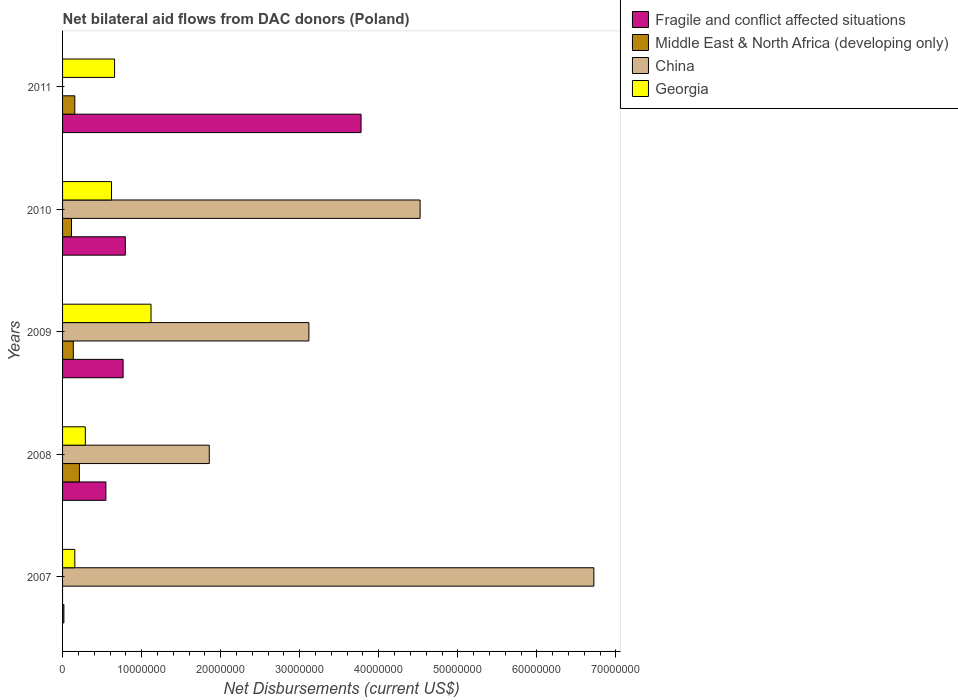Are the number of bars per tick equal to the number of legend labels?
Keep it short and to the point. No. Are the number of bars on each tick of the Y-axis equal?
Provide a succinct answer. No. How many bars are there on the 5th tick from the top?
Your response must be concise. 3. What is the label of the 2nd group of bars from the top?
Offer a very short reply. 2010. In how many cases, is the number of bars for a given year not equal to the number of legend labels?
Offer a very short reply. 2. What is the net bilateral aid flows in Fragile and conflict affected situations in 2010?
Your response must be concise. 7.94e+06. Across all years, what is the maximum net bilateral aid flows in China?
Keep it short and to the point. 6.72e+07. Across all years, what is the minimum net bilateral aid flows in Fragile and conflict affected situations?
Keep it short and to the point. 1.70e+05. What is the total net bilateral aid flows in Middle East & North Africa (developing only) in the graph?
Provide a short and direct response. 6.17e+06. What is the difference between the net bilateral aid flows in Fragile and conflict affected situations in 2007 and that in 2011?
Your answer should be compact. -3.76e+07. What is the difference between the net bilateral aid flows in China in 2010 and the net bilateral aid flows in Middle East & North Africa (developing only) in 2007?
Make the answer very short. 4.52e+07. What is the average net bilateral aid flows in Fragile and conflict affected situations per year?
Keep it short and to the point. 1.18e+07. In the year 2010, what is the difference between the net bilateral aid flows in Georgia and net bilateral aid flows in Fragile and conflict affected situations?
Make the answer very short. -1.75e+06. In how many years, is the net bilateral aid flows in China greater than 10000000 US$?
Your answer should be compact. 4. What is the ratio of the net bilateral aid flows in Middle East & North Africa (developing only) in 2008 to that in 2011?
Give a very brief answer. 1.37. Is the net bilateral aid flows in China in 2007 less than that in 2009?
Provide a short and direct response. No. Is the difference between the net bilateral aid flows in Georgia in 2008 and 2009 greater than the difference between the net bilateral aid flows in Fragile and conflict affected situations in 2008 and 2009?
Your response must be concise. No. What is the difference between the highest and the second highest net bilateral aid flows in Middle East & North Africa (developing only)?
Your answer should be very brief. 5.80e+05. What is the difference between the highest and the lowest net bilateral aid flows in China?
Make the answer very short. 6.72e+07. In how many years, is the net bilateral aid flows in Middle East & North Africa (developing only) greater than the average net bilateral aid flows in Middle East & North Africa (developing only) taken over all years?
Ensure brevity in your answer.  3. Is it the case that in every year, the sum of the net bilateral aid flows in Georgia and net bilateral aid flows in Fragile and conflict affected situations is greater than the net bilateral aid flows in Middle East & North Africa (developing only)?
Make the answer very short. Yes. What is the difference between two consecutive major ticks on the X-axis?
Your answer should be compact. 1.00e+07. Does the graph contain any zero values?
Offer a very short reply. Yes. What is the title of the graph?
Ensure brevity in your answer.  Net bilateral aid flows from DAC donors (Poland). Does "Poland" appear as one of the legend labels in the graph?
Keep it short and to the point. No. What is the label or title of the X-axis?
Your answer should be compact. Net Disbursements (current US$). What is the Net Disbursements (current US$) in Fragile and conflict affected situations in 2007?
Ensure brevity in your answer.  1.70e+05. What is the Net Disbursements (current US$) in Middle East & North Africa (developing only) in 2007?
Offer a terse response. 0. What is the Net Disbursements (current US$) in China in 2007?
Offer a very short reply. 6.72e+07. What is the Net Disbursements (current US$) in Georgia in 2007?
Provide a short and direct response. 1.55e+06. What is the Net Disbursements (current US$) in Fragile and conflict affected situations in 2008?
Your response must be concise. 5.48e+06. What is the Net Disbursements (current US$) in Middle East & North Africa (developing only) in 2008?
Offer a terse response. 2.13e+06. What is the Net Disbursements (current US$) of China in 2008?
Provide a short and direct response. 1.86e+07. What is the Net Disbursements (current US$) of Georgia in 2008?
Provide a succinct answer. 2.88e+06. What is the Net Disbursements (current US$) of Fragile and conflict affected situations in 2009?
Give a very brief answer. 7.66e+06. What is the Net Disbursements (current US$) in Middle East & North Africa (developing only) in 2009?
Provide a short and direct response. 1.36e+06. What is the Net Disbursements (current US$) in China in 2009?
Your response must be concise. 3.12e+07. What is the Net Disbursements (current US$) in Georgia in 2009?
Make the answer very short. 1.12e+07. What is the Net Disbursements (current US$) in Fragile and conflict affected situations in 2010?
Your answer should be compact. 7.94e+06. What is the Net Disbursements (current US$) of Middle East & North Africa (developing only) in 2010?
Make the answer very short. 1.13e+06. What is the Net Disbursements (current US$) in China in 2010?
Keep it short and to the point. 4.52e+07. What is the Net Disbursements (current US$) of Georgia in 2010?
Offer a terse response. 6.19e+06. What is the Net Disbursements (current US$) of Fragile and conflict affected situations in 2011?
Keep it short and to the point. 3.78e+07. What is the Net Disbursements (current US$) of Middle East & North Africa (developing only) in 2011?
Offer a very short reply. 1.55e+06. What is the Net Disbursements (current US$) in China in 2011?
Offer a terse response. 0. What is the Net Disbursements (current US$) in Georgia in 2011?
Ensure brevity in your answer.  6.58e+06. Across all years, what is the maximum Net Disbursements (current US$) of Fragile and conflict affected situations?
Make the answer very short. 3.78e+07. Across all years, what is the maximum Net Disbursements (current US$) in Middle East & North Africa (developing only)?
Ensure brevity in your answer.  2.13e+06. Across all years, what is the maximum Net Disbursements (current US$) of China?
Keep it short and to the point. 6.72e+07. Across all years, what is the maximum Net Disbursements (current US$) of Georgia?
Offer a terse response. 1.12e+07. Across all years, what is the minimum Net Disbursements (current US$) of China?
Your answer should be compact. 0. Across all years, what is the minimum Net Disbursements (current US$) in Georgia?
Ensure brevity in your answer.  1.55e+06. What is the total Net Disbursements (current US$) in Fragile and conflict affected situations in the graph?
Provide a short and direct response. 5.90e+07. What is the total Net Disbursements (current US$) of Middle East & North Africa (developing only) in the graph?
Ensure brevity in your answer.  6.17e+06. What is the total Net Disbursements (current US$) of China in the graph?
Offer a terse response. 1.62e+08. What is the total Net Disbursements (current US$) in Georgia in the graph?
Your answer should be compact. 2.84e+07. What is the difference between the Net Disbursements (current US$) in Fragile and conflict affected situations in 2007 and that in 2008?
Ensure brevity in your answer.  -5.31e+06. What is the difference between the Net Disbursements (current US$) in China in 2007 and that in 2008?
Offer a very short reply. 4.86e+07. What is the difference between the Net Disbursements (current US$) of Georgia in 2007 and that in 2008?
Provide a succinct answer. -1.33e+06. What is the difference between the Net Disbursements (current US$) of Fragile and conflict affected situations in 2007 and that in 2009?
Your answer should be compact. -7.49e+06. What is the difference between the Net Disbursements (current US$) of China in 2007 and that in 2009?
Offer a terse response. 3.60e+07. What is the difference between the Net Disbursements (current US$) of Georgia in 2007 and that in 2009?
Offer a terse response. -9.64e+06. What is the difference between the Net Disbursements (current US$) in Fragile and conflict affected situations in 2007 and that in 2010?
Offer a very short reply. -7.77e+06. What is the difference between the Net Disbursements (current US$) in China in 2007 and that in 2010?
Provide a short and direct response. 2.20e+07. What is the difference between the Net Disbursements (current US$) in Georgia in 2007 and that in 2010?
Make the answer very short. -4.64e+06. What is the difference between the Net Disbursements (current US$) of Fragile and conflict affected situations in 2007 and that in 2011?
Provide a short and direct response. -3.76e+07. What is the difference between the Net Disbursements (current US$) in Georgia in 2007 and that in 2011?
Your answer should be compact. -5.03e+06. What is the difference between the Net Disbursements (current US$) in Fragile and conflict affected situations in 2008 and that in 2009?
Provide a short and direct response. -2.18e+06. What is the difference between the Net Disbursements (current US$) in Middle East & North Africa (developing only) in 2008 and that in 2009?
Ensure brevity in your answer.  7.70e+05. What is the difference between the Net Disbursements (current US$) in China in 2008 and that in 2009?
Make the answer very short. -1.26e+07. What is the difference between the Net Disbursements (current US$) of Georgia in 2008 and that in 2009?
Keep it short and to the point. -8.31e+06. What is the difference between the Net Disbursements (current US$) in Fragile and conflict affected situations in 2008 and that in 2010?
Offer a terse response. -2.46e+06. What is the difference between the Net Disbursements (current US$) of Middle East & North Africa (developing only) in 2008 and that in 2010?
Provide a short and direct response. 1.00e+06. What is the difference between the Net Disbursements (current US$) of China in 2008 and that in 2010?
Ensure brevity in your answer.  -2.67e+07. What is the difference between the Net Disbursements (current US$) in Georgia in 2008 and that in 2010?
Make the answer very short. -3.31e+06. What is the difference between the Net Disbursements (current US$) in Fragile and conflict affected situations in 2008 and that in 2011?
Your answer should be compact. -3.23e+07. What is the difference between the Net Disbursements (current US$) of Middle East & North Africa (developing only) in 2008 and that in 2011?
Offer a terse response. 5.80e+05. What is the difference between the Net Disbursements (current US$) of Georgia in 2008 and that in 2011?
Your response must be concise. -3.70e+06. What is the difference between the Net Disbursements (current US$) in Fragile and conflict affected situations in 2009 and that in 2010?
Your answer should be compact. -2.80e+05. What is the difference between the Net Disbursements (current US$) in Middle East & North Africa (developing only) in 2009 and that in 2010?
Keep it short and to the point. 2.30e+05. What is the difference between the Net Disbursements (current US$) of China in 2009 and that in 2010?
Offer a terse response. -1.41e+07. What is the difference between the Net Disbursements (current US$) in Georgia in 2009 and that in 2010?
Your answer should be compact. 5.00e+06. What is the difference between the Net Disbursements (current US$) of Fragile and conflict affected situations in 2009 and that in 2011?
Provide a short and direct response. -3.01e+07. What is the difference between the Net Disbursements (current US$) of Middle East & North Africa (developing only) in 2009 and that in 2011?
Ensure brevity in your answer.  -1.90e+05. What is the difference between the Net Disbursements (current US$) in Georgia in 2009 and that in 2011?
Provide a short and direct response. 4.61e+06. What is the difference between the Net Disbursements (current US$) in Fragile and conflict affected situations in 2010 and that in 2011?
Your answer should be very brief. -2.98e+07. What is the difference between the Net Disbursements (current US$) in Middle East & North Africa (developing only) in 2010 and that in 2011?
Give a very brief answer. -4.20e+05. What is the difference between the Net Disbursements (current US$) in Georgia in 2010 and that in 2011?
Provide a succinct answer. -3.90e+05. What is the difference between the Net Disbursements (current US$) of Fragile and conflict affected situations in 2007 and the Net Disbursements (current US$) of Middle East & North Africa (developing only) in 2008?
Your answer should be very brief. -1.96e+06. What is the difference between the Net Disbursements (current US$) in Fragile and conflict affected situations in 2007 and the Net Disbursements (current US$) in China in 2008?
Offer a terse response. -1.84e+07. What is the difference between the Net Disbursements (current US$) of Fragile and conflict affected situations in 2007 and the Net Disbursements (current US$) of Georgia in 2008?
Make the answer very short. -2.71e+06. What is the difference between the Net Disbursements (current US$) in China in 2007 and the Net Disbursements (current US$) in Georgia in 2008?
Give a very brief answer. 6.43e+07. What is the difference between the Net Disbursements (current US$) of Fragile and conflict affected situations in 2007 and the Net Disbursements (current US$) of Middle East & North Africa (developing only) in 2009?
Give a very brief answer. -1.19e+06. What is the difference between the Net Disbursements (current US$) in Fragile and conflict affected situations in 2007 and the Net Disbursements (current US$) in China in 2009?
Your answer should be compact. -3.10e+07. What is the difference between the Net Disbursements (current US$) of Fragile and conflict affected situations in 2007 and the Net Disbursements (current US$) of Georgia in 2009?
Provide a succinct answer. -1.10e+07. What is the difference between the Net Disbursements (current US$) in China in 2007 and the Net Disbursements (current US$) in Georgia in 2009?
Your answer should be compact. 5.60e+07. What is the difference between the Net Disbursements (current US$) in Fragile and conflict affected situations in 2007 and the Net Disbursements (current US$) in Middle East & North Africa (developing only) in 2010?
Give a very brief answer. -9.60e+05. What is the difference between the Net Disbursements (current US$) in Fragile and conflict affected situations in 2007 and the Net Disbursements (current US$) in China in 2010?
Ensure brevity in your answer.  -4.51e+07. What is the difference between the Net Disbursements (current US$) of Fragile and conflict affected situations in 2007 and the Net Disbursements (current US$) of Georgia in 2010?
Provide a short and direct response. -6.02e+06. What is the difference between the Net Disbursements (current US$) of China in 2007 and the Net Disbursements (current US$) of Georgia in 2010?
Offer a terse response. 6.10e+07. What is the difference between the Net Disbursements (current US$) of Fragile and conflict affected situations in 2007 and the Net Disbursements (current US$) of Middle East & North Africa (developing only) in 2011?
Your response must be concise. -1.38e+06. What is the difference between the Net Disbursements (current US$) in Fragile and conflict affected situations in 2007 and the Net Disbursements (current US$) in Georgia in 2011?
Your response must be concise. -6.41e+06. What is the difference between the Net Disbursements (current US$) of China in 2007 and the Net Disbursements (current US$) of Georgia in 2011?
Your answer should be compact. 6.06e+07. What is the difference between the Net Disbursements (current US$) in Fragile and conflict affected situations in 2008 and the Net Disbursements (current US$) in Middle East & North Africa (developing only) in 2009?
Offer a terse response. 4.12e+06. What is the difference between the Net Disbursements (current US$) of Fragile and conflict affected situations in 2008 and the Net Disbursements (current US$) of China in 2009?
Ensure brevity in your answer.  -2.57e+07. What is the difference between the Net Disbursements (current US$) of Fragile and conflict affected situations in 2008 and the Net Disbursements (current US$) of Georgia in 2009?
Ensure brevity in your answer.  -5.71e+06. What is the difference between the Net Disbursements (current US$) of Middle East & North Africa (developing only) in 2008 and the Net Disbursements (current US$) of China in 2009?
Ensure brevity in your answer.  -2.90e+07. What is the difference between the Net Disbursements (current US$) in Middle East & North Africa (developing only) in 2008 and the Net Disbursements (current US$) in Georgia in 2009?
Your answer should be very brief. -9.06e+06. What is the difference between the Net Disbursements (current US$) of China in 2008 and the Net Disbursements (current US$) of Georgia in 2009?
Offer a very short reply. 7.37e+06. What is the difference between the Net Disbursements (current US$) of Fragile and conflict affected situations in 2008 and the Net Disbursements (current US$) of Middle East & North Africa (developing only) in 2010?
Make the answer very short. 4.35e+06. What is the difference between the Net Disbursements (current US$) in Fragile and conflict affected situations in 2008 and the Net Disbursements (current US$) in China in 2010?
Keep it short and to the point. -3.98e+07. What is the difference between the Net Disbursements (current US$) of Fragile and conflict affected situations in 2008 and the Net Disbursements (current US$) of Georgia in 2010?
Give a very brief answer. -7.10e+05. What is the difference between the Net Disbursements (current US$) in Middle East & North Africa (developing only) in 2008 and the Net Disbursements (current US$) in China in 2010?
Offer a very short reply. -4.31e+07. What is the difference between the Net Disbursements (current US$) of Middle East & North Africa (developing only) in 2008 and the Net Disbursements (current US$) of Georgia in 2010?
Your response must be concise. -4.06e+06. What is the difference between the Net Disbursements (current US$) of China in 2008 and the Net Disbursements (current US$) of Georgia in 2010?
Your response must be concise. 1.24e+07. What is the difference between the Net Disbursements (current US$) of Fragile and conflict affected situations in 2008 and the Net Disbursements (current US$) of Middle East & North Africa (developing only) in 2011?
Offer a terse response. 3.93e+06. What is the difference between the Net Disbursements (current US$) of Fragile and conflict affected situations in 2008 and the Net Disbursements (current US$) of Georgia in 2011?
Offer a terse response. -1.10e+06. What is the difference between the Net Disbursements (current US$) in Middle East & North Africa (developing only) in 2008 and the Net Disbursements (current US$) in Georgia in 2011?
Make the answer very short. -4.45e+06. What is the difference between the Net Disbursements (current US$) in China in 2008 and the Net Disbursements (current US$) in Georgia in 2011?
Offer a terse response. 1.20e+07. What is the difference between the Net Disbursements (current US$) in Fragile and conflict affected situations in 2009 and the Net Disbursements (current US$) in Middle East & North Africa (developing only) in 2010?
Offer a terse response. 6.53e+06. What is the difference between the Net Disbursements (current US$) of Fragile and conflict affected situations in 2009 and the Net Disbursements (current US$) of China in 2010?
Offer a terse response. -3.76e+07. What is the difference between the Net Disbursements (current US$) of Fragile and conflict affected situations in 2009 and the Net Disbursements (current US$) of Georgia in 2010?
Provide a short and direct response. 1.47e+06. What is the difference between the Net Disbursements (current US$) of Middle East & North Africa (developing only) in 2009 and the Net Disbursements (current US$) of China in 2010?
Your response must be concise. -4.39e+07. What is the difference between the Net Disbursements (current US$) in Middle East & North Africa (developing only) in 2009 and the Net Disbursements (current US$) in Georgia in 2010?
Give a very brief answer. -4.83e+06. What is the difference between the Net Disbursements (current US$) in China in 2009 and the Net Disbursements (current US$) in Georgia in 2010?
Your answer should be very brief. 2.50e+07. What is the difference between the Net Disbursements (current US$) of Fragile and conflict affected situations in 2009 and the Net Disbursements (current US$) of Middle East & North Africa (developing only) in 2011?
Your answer should be very brief. 6.11e+06. What is the difference between the Net Disbursements (current US$) in Fragile and conflict affected situations in 2009 and the Net Disbursements (current US$) in Georgia in 2011?
Provide a succinct answer. 1.08e+06. What is the difference between the Net Disbursements (current US$) in Middle East & North Africa (developing only) in 2009 and the Net Disbursements (current US$) in Georgia in 2011?
Offer a very short reply. -5.22e+06. What is the difference between the Net Disbursements (current US$) of China in 2009 and the Net Disbursements (current US$) of Georgia in 2011?
Provide a succinct answer. 2.46e+07. What is the difference between the Net Disbursements (current US$) in Fragile and conflict affected situations in 2010 and the Net Disbursements (current US$) in Middle East & North Africa (developing only) in 2011?
Provide a short and direct response. 6.39e+06. What is the difference between the Net Disbursements (current US$) in Fragile and conflict affected situations in 2010 and the Net Disbursements (current US$) in Georgia in 2011?
Offer a very short reply. 1.36e+06. What is the difference between the Net Disbursements (current US$) of Middle East & North Africa (developing only) in 2010 and the Net Disbursements (current US$) of Georgia in 2011?
Ensure brevity in your answer.  -5.45e+06. What is the difference between the Net Disbursements (current US$) in China in 2010 and the Net Disbursements (current US$) in Georgia in 2011?
Your answer should be very brief. 3.86e+07. What is the average Net Disbursements (current US$) of Fragile and conflict affected situations per year?
Provide a short and direct response. 1.18e+07. What is the average Net Disbursements (current US$) of Middle East & North Africa (developing only) per year?
Ensure brevity in your answer.  1.23e+06. What is the average Net Disbursements (current US$) in China per year?
Make the answer very short. 3.24e+07. What is the average Net Disbursements (current US$) of Georgia per year?
Keep it short and to the point. 5.68e+06. In the year 2007, what is the difference between the Net Disbursements (current US$) in Fragile and conflict affected situations and Net Disbursements (current US$) in China?
Give a very brief answer. -6.70e+07. In the year 2007, what is the difference between the Net Disbursements (current US$) of Fragile and conflict affected situations and Net Disbursements (current US$) of Georgia?
Provide a succinct answer. -1.38e+06. In the year 2007, what is the difference between the Net Disbursements (current US$) in China and Net Disbursements (current US$) in Georgia?
Your answer should be compact. 6.57e+07. In the year 2008, what is the difference between the Net Disbursements (current US$) of Fragile and conflict affected situations and Net Disbursements (current US$) of Middle East & North Africa (developing only)?
Your answer should be compact. 3.35e+06. In the year 2008, what is the difference between the Net Disbursements (current US$) in Fragile and conflict affected situations and Net Disbursements (current US$) in China?
Provide a short and direct response. -1.31e+07. In the year 2008, what is the difference between the Net Disbursements (current US$) in Fragile and conflict affected situations and Net Disbursements (current US$) in Georgia?
Offer a very short reply. 2.60e+06. In the year 2008, what is the difference between the Net Disbursements (current US$) in Middle East & North Africa (developing only) and Net Disbursements (current US$) in China?
Provide a short and direct response. -1.64e+07. In the year 2008, what is the difference between the Net Disbursements (current US$) in Middle East & North Africa (developing only) and Net Disbursements (current US$) in Georgia?
Your response must be concise. -7.50e+05. In the year 2008, what is the difference between the Net Disbursements (current US$) of China and Net Disbursements (current US$) of Georgia?
Ensure brevity in your answer.  1.57e+07. In the year 2009, what is the difference between the Net Disbursements (current US$) of Fragile and conflict affected situations and Net Disbursements (current US$) of Middle East & North Africa (developing only)?
Give a very brief answer. 6.30e+06. In the year 2009, what is the difference between the Net Disbursements (current US$) of Fragile and conflict affected situations and Net Disbursements (current US$) of China?
Ensure brevity in your answer.  -2.35e+07. In the year 2009, what is the difference between the Net Disbursements (current US$) of Fragile and conflict affected situations and Net Disbursements (current US$) of Georgia?
Offer a terse response. -3.53e+06. In the year 2009, what is the difference between the Net Disbursements (current US$) in Middle East & North Africa (developing only) and Net Disbursements (current US$) in China?
Your answer should be compact. -2.98e+07. In the year 2009, what is the difference between the Net Disbursements (current US$) of Middle East & North Africa (developing only) and Net Disbursements (current US$) of Georgia?
Offer a terse response. -9.83e+06. In the year 2009, what is the difference between the Net Disbursements (current US$) in China and Net Disbursements (current US$) in Georgia?
Your response must be concise. 2.00e+07. In the year 2010, what is the difference between the Net Disbursements (current US$) in Fragile and conflict affected situations and Net Disbursements (current US$) in Middle East & North Africa (developing only)?
Your answer should be very brief. 6.81e+06. In the year 2010, what is the difference between the Net Disbursements (current US$) in Fragile and conflict affected situations and Net Disbursements (current US$) in China?
Keep it short and to the point. -3.73e+07. In the year 2010, what is the difference between the Net Disbursements (current US$) of Fragile and conflict affected situations and Net Disbursements (current US$) of Georgia?
Ensure brevity in your answer.  1.75e+06. In the year 2010, what is the difference between the Net Disbursements (current US$) in Middle East & North Africa (developing only) and Net Disbursements (current US$) in China?
Offer a very short reply. -4.41e+07. In the year 2010, what is the difference between the Net Disbursements (current US$) in Middle East & North Africa (developing only) and Net Disbursements (current US$) in Georgia?
Make the answer very short. -5.06e+06. In the year 2010, what is the difference between the Net Disbursements (current US$) of China and Net Disbursements (current US$) of Georgia?
Keep it short and to the point. 3.90e+07. In the year 2011, what is the difference between the Net Disbursements (current US$) in Fragile and conflict affected situations and Net Disbursements (current US$) in Middle East & North Africa (developing only)?
Make the answer very short. 3.62e+07. In the year 2011, what is the difference between the Net Disbursements (current US$) of Fragile and conflict affected situations and Net Disbursements (current US$) of Georgia?
Offer a terse response. 3.12e+07. In the year 2011, what is the difference between the Net Disbursements (current US$) of Middle East & North Africa (developing only) and Net Disbursements (current US$) of Georgia?
Ensure brevity in your answer.  -5.03e+06. What is the ratio of the Net Disbursements (current US$) of Fragile and conflict affected situations in 2007 to that in 2008?
Give a very brief answer. 0.03. What is the ratio of the Net Disbursements (current US$) in China in 2007 to that in 2008?
Keep it short and to the point. 3.62. What is the ratio of the Net Disbursements (current US$) of Georgia in 2007 to that in 2008?
Make the answer very short. 0.54. What is the ratio of the Net Disbursements (current US$) of Fragile and conflict affected situations in 2007 to that in 2009?
Give a very brief answer. 0.02. What is the ratio of the Net Disbursements (current US$) in China in 2007 to that in 2009?
Ensure brevity in your answer.  2.16. What is the ratio of the Net Disbursements (current US$) of Georgia in 2007 to that in 2009?
Your answer should be compact. 0.14. What is the ratio of the Net Disbursements (current US$) in Fragile and conflict affected situations in 2007 to that in 2010?
Provide a short and direct response. 0.02. What is the ratio of the Net Disbursements (current US$) in China in 2007 to that in 2010?
Make the answer very short. 1.49. What is the ratio of the Net Disbursements (current US$) of Georgia in 2007 to that in 2010?
Give a very brief answer. 0.25. What is the ratio of the Net Disbursements (current US$) in Fragile and conflict affected situations in 2007 to that in 2011?
Your answer should be compact. 0. What is the ratio of the Net Disbursements (current US$) of Georgia in 2007 to that in 2011?
Offer a very short reply. 0.24. What is the ratio of the Net Disbursements (current US$) in Fragile and conflict affected situations in 2008 to that in 2009?
Provide a succinct answer. 0.72. What is the ratio of the Net Disbursements (current US$) in Middle East & North Africa (developing only) in 2008 to that in 2009?
Provide a short and direct response. 1.57. What is the ratio of the Net Disbursements (current US$) of China in 2008 to that in 2009?
Offer a very short reply. 0.6. What is the ratio of the Net Disbursements (current US$) in Georgia in 2008 to that in 2009?
Make the answer very short. 0.26. What is the ratio of the Net Disbursements (current US$) in Fragile and conflict affected situations in 2008 to that in 2010?
Keep it short and to the point. 0.69. What is the ratio of the Net Disbursements (current US$) in Middle East & North Africa (developing only) in 2008 to that in 2010?
Make the answer very short. 1.89. What is the ratio of the Net Disbursements (current US$) of China in 2008 to that in 2010?
Offer a very short reply. 0.41. What is the ratio of the Net Disbursements (current US$) of Georgia in 2008 to that in 2010?
Your answer should be compact. 0.47. What is the ratio of the Net Disbursements (current US$) of Fragile and conflict affected situations in 2008 to that in 2011?
Make the answer very short. 0.15. What is the ratio of the Net Disbursements (current US$) of Middle East & North Africa (developing only) in 2008 to that in 2011?
Offer a terse response. 1.37. What is the ratio of the Net Disbursements (current US$) of Georgia in 2008 to that in 2011?
Provide a short and direct response. 0.44. What is the ratio of the Net Disbursements (current US$) of Fragile and conflict affected situations in 2009 to that in 2010?
Give a very brief answer. 0.96. What is the ratio of the Net Disbursements (current US$) in Middle East & North Africa (developing only) in 2009 to that in 2010?
Offer a very short reply. 1.2. What is the ratio of the Net Disbursements (current US$) of China in 2009 to that in 2010?
Offer a very short reply. 0.69. What is the ratio of the Net Disbursements (current US$) of Georgia in 2009 to that in 2010?
Offer a terse response. 1.81. What is the ratio of the Net Disbursements (current US$) in Fragile and conflict affected situations in 2009 to that in 2011?
Provide a short and direct response. 0.2. What is the ratio of the Net Disbursements (current US$) in Middle East & North Africa (developing only) in 2009 to that in 2011?
Provide a succinct answer. 0.88. What is the ratio of the Net Disbursements (current US$) of Georgia in 2009 to that in 2011?
Keep it short and to the point. 1.7. What is the ratio of the Net Disbursements (current US$) of Fragile and conflict affected situations in 2010 to that in 2011?
Ensure brevity in your answer.  0.21. What is the ratio of the Net Disbursements (current US$) of Middle East & North Africa (developing only) in 2010 to that in 2011?
Give a very brief answer. 0.73. What is the ratio of the Net Disbursements (current US$) in Georgia in 2010 to that in 2011?
Offer a terse response. 0.94. What is the difference between the highest and the second highest Net Disbursements (current US$) of Fragile and conflict affected situations?
Offer a terse response. 2.98e+07. What is the difference between the highest and the second highest Net Disbursements (current US$) in Middle East & North Africa (developing only)?
Offer a terse response. 5.80e+05. What is the difference between the highest and the second highest Net Disbursements (current US$) in China?
Provide a succinct answer. 2.20e+07. What is the difference between the highest and the second highest Net Disbursements (current US$) in Georgia?
Ensure brevity in your answer.  4.61e+06. What is the difference between the highest and the lowest Net Disbursements (current US$) in Fragile and conflict affected situations?
Your response must be concise. 3.76e+07. What is the difference between the highest and the lowest Net Disbursements (current US$) in Middle East & North Africa (developing only)?
Make the answer very short. 2.13e+06. What is the difference between the highest and the lowest Net Disbursements (current US$) in China?
Your response must be concise. 6.72e+07. What is the difference between the highest and the lowest Net Disbursements (current US$) of Georgia?
Provide a short and direct response. 9.64e+06. 